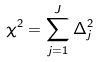Convert formula to latex. <formula><loc_0><loc_0><loc_500><loc_500>\chi ^ { 2 } = \sum _ { j = 1 } ^ { J } \Delta _ { j } ^ { 2 }</formula> 